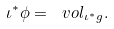Convert formula to latex. <formula><loc_0><loc_0><loc_500><loc_500>\iota ^ { * } \phi = \ v o l _ { \iota ^ { * } g } .</formula> 